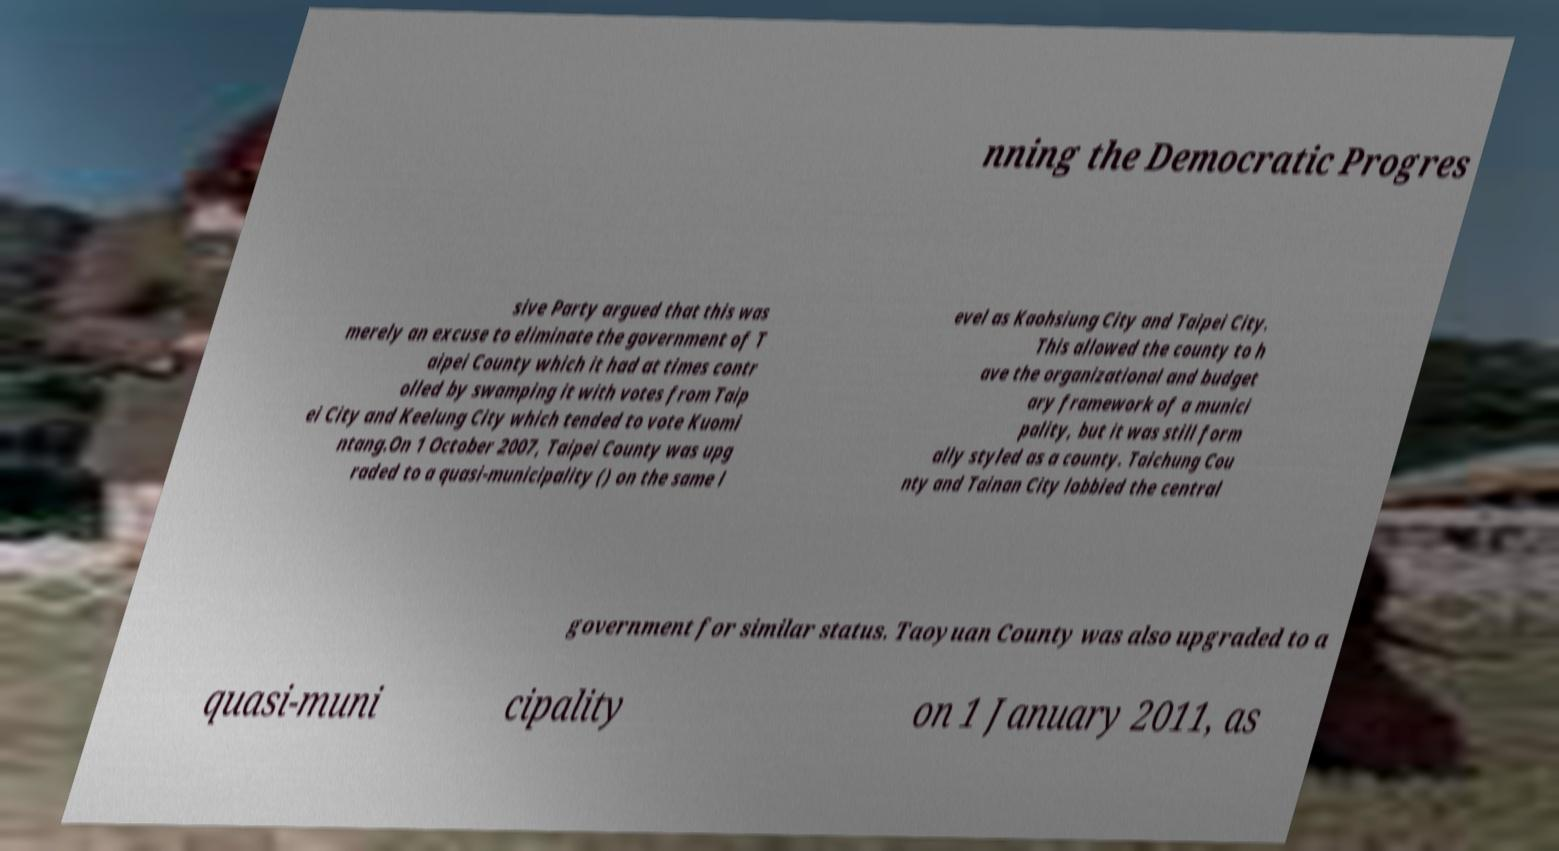Please read and relay the text visible in this image. What does it say? nning the Democratic Progres sive Party argued that this was merely an excuse to eliminate the government of T aipei County which it had at times contr olled by swamping it with votes from Taip ei City and Keelung City which tended to vote Kuomi ntang.On 1 October 2007, Taipei County was upg raded to a quasi-municipality () on the same l evel as Kaohsiung City and Taipei City. This allowed the county to h ave the organizational and budget ary framework of a munici pality, but it was still form ally styled as a county. Taichung Cou nty and Tainan City lobbied the central government for similar status. Taoyuan County was also upgraded to a quasi-muni cipality on 1 January 2011, as 